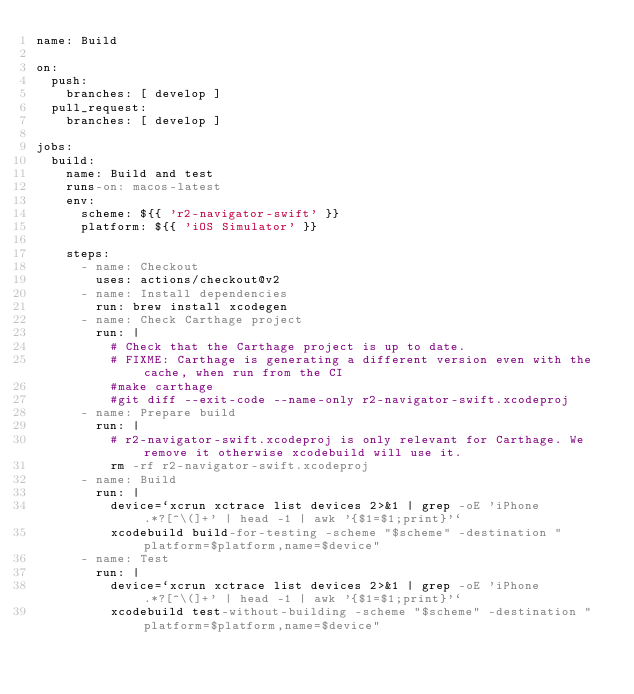<code> <loc_0><loc_0><loc_500><loc_500><_YAML_>name: Build

on:
  push:
    branches: [ develop ]
  pull_request:
    branches: [ develop ]

jobs:
  build:
    name: Build and test
    runs-on: macos-latest
    env:
      scheme: ${{ 'r2-navigator-swift' }}
      platform: ${{ 'iOS Simulator' }}

    steps:
      - name: Checkout
        uses: actions/checkout@v2
      - name: Install dependencies
        run: brew install xcodegen
      - name: Check Carthage project
        run: |
          # Check that the Carthage project is up to date.
          # FIXME: Carthage is generating a different version even with the cache, when run from the CI
          #make carthage
          #git diff --exit-code --name-only r2-navigator-swift.xcodeproj
      - name: Prepare build
        run: |
          # r2-navigator-swift.xcodeproj is only relevant for Carthage. We remove it otherwise xcodebuild will use it.
          rm -rf r2-navigator-swift.xcodeproj
      - name: Build
        run: |
          device=`xcrun xctrace list devices 2>&1 | grep -oE 'iPhone.*?[^\(]+' | head -1 | awk '{$1=$1;print}'`
          xcodebuild build-for-testing -scheme "$scheme" -destination "platform=$platform,name=$device"
      - name: Test
        run: |
          device=`xcrun xctrace list devices 2>&1 | grep -oE 'iPhone.*?[^\(]+' | head -1 | awk '{$1=$1;print}'`
          xcodebuild test-without-building -scheme "$scheme" -destination "platform=$platform,name=$device"
</code> 